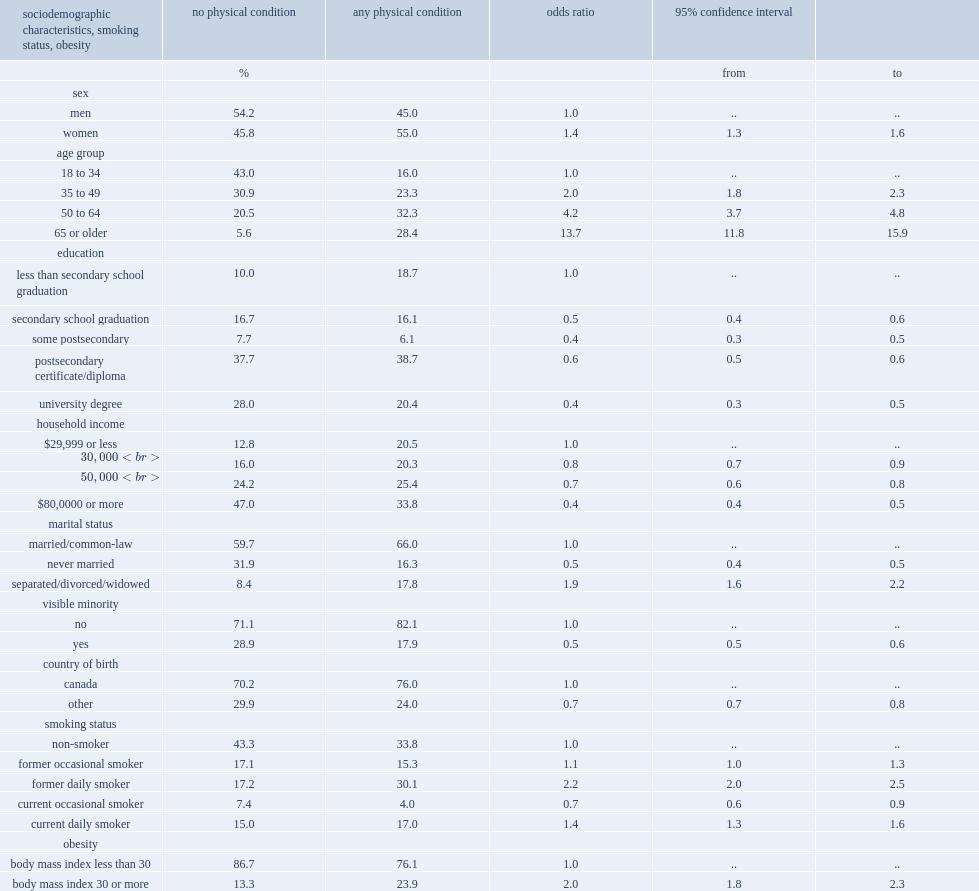Which group of people had a higher prevalence of having a physical condition? women or men? Women. 